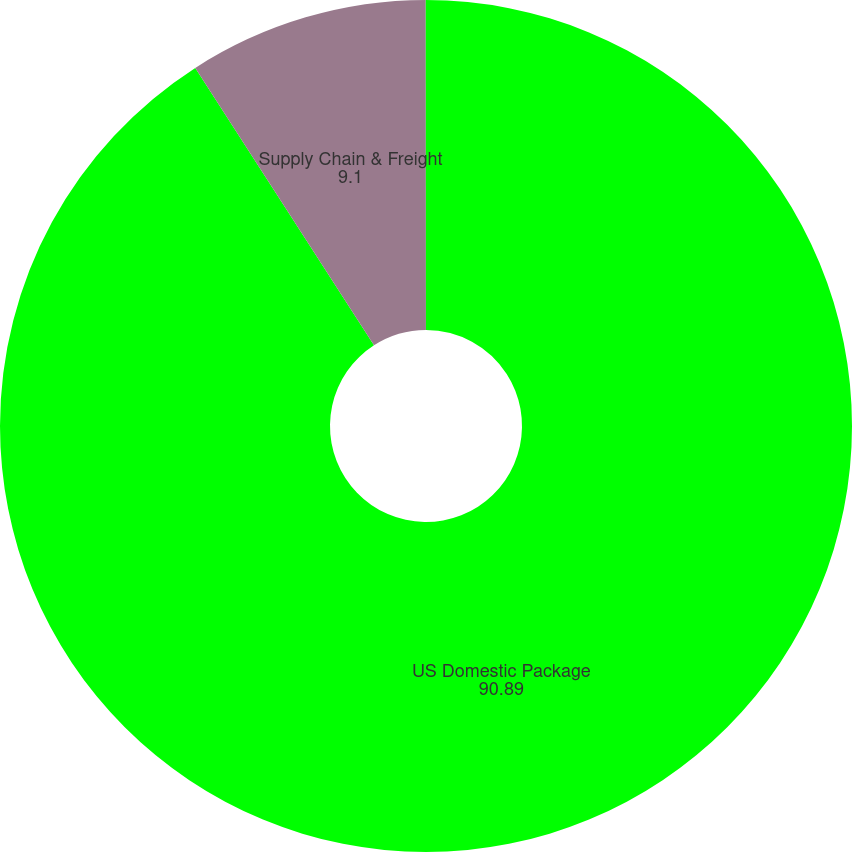<chart> <loc_0><loc_0><loc_500><loc_500><pie_chart><fcel>US Domestic Package<fcel>Supply Chain & Freight<fcel>Diluted<nl><fcel>90.89%<fcel>9.1%<fcel>0.01%<nl></chart> 